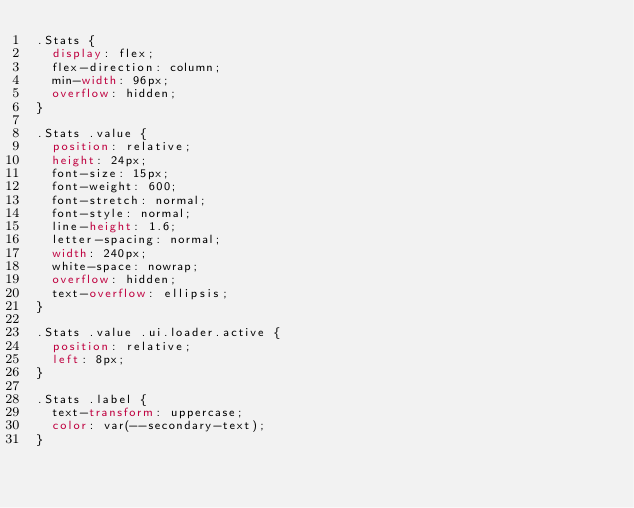Convert code to text. <code><loc_0><loc_0><loc_500><loc_500><_CSS_>.Stats {
  display: flex;
  flex-direction: column;
  min-width: 96px;
  overflow: hidden;
}

.Stats .value {
  position: relative;
  height: 24px;
  font-size: 15px;
  font-weight: 600;
  font-stretch: normal;
  font-style: normal;
  line-height: 1.6;
  letter-spacing: normal;
  width: 240px;
  white-space: nowrap;
  overflow: hidden;
  text-overflow: ellipsis;
}

.Stats .value .ui.loader.active {
  position: relative;
  left: 8px;
}

.Stats .label {
  text-transform: uppercase;
  color: var(--secondary-text);
}
</code> 